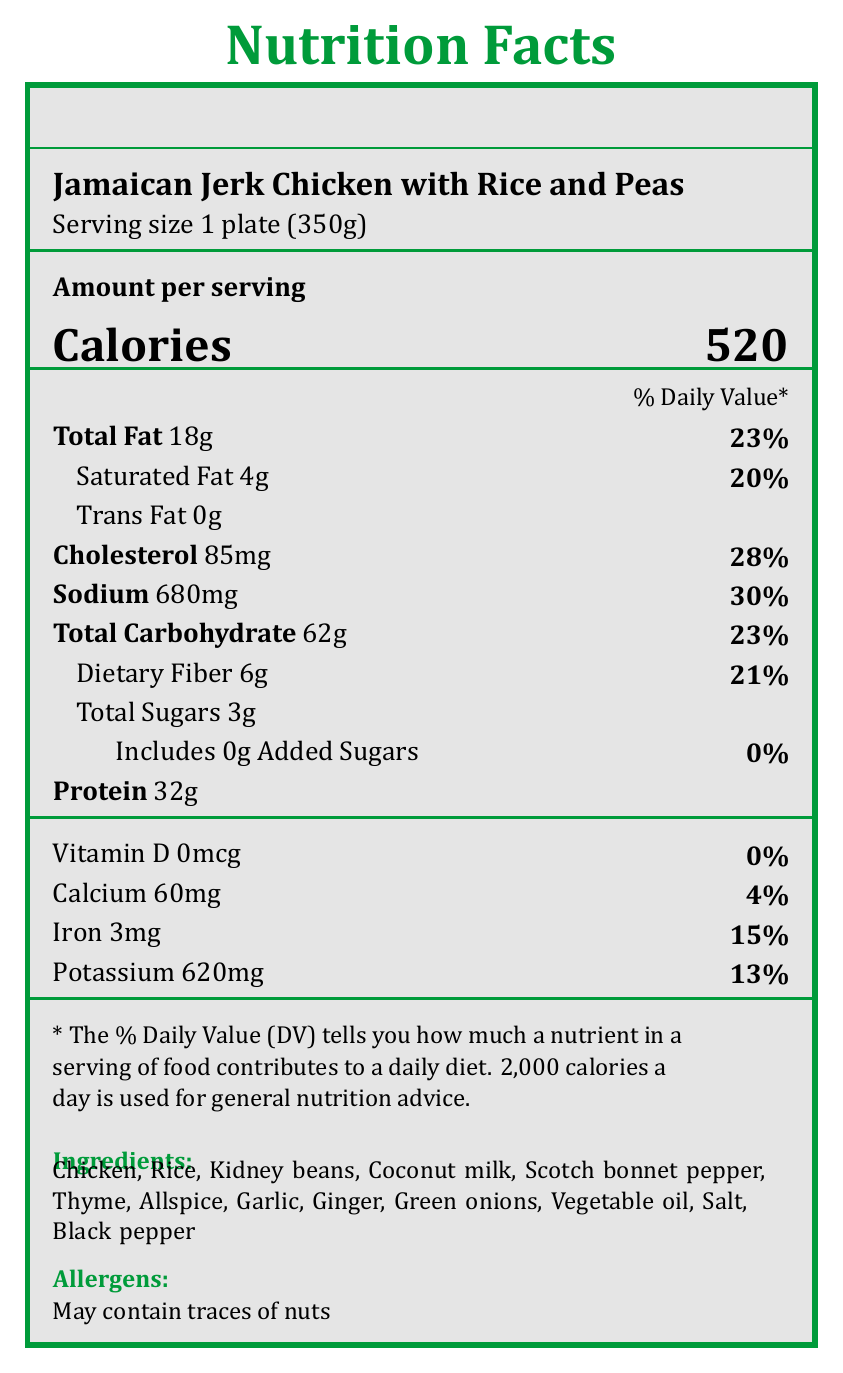what is the serving size for Jamaican Jerk Chicken with Rice and Peas? The serving size is clearly listed as 1 plate (350g) under the dish name in the nutrition facts.
Answer: 1 plate (350g) how many calories does one serving of this dish contain? The calories are prominently displayed as 520 in large font under the "Amount per serving" section.
Answer: 520 what is the amount of total fat in one serving? The total fat content is listed as 18g in the nutrition facts section.
Answer: 18g what percentage of the daily value of sodium does this dish provide? The sodium content is listed as 680mg, which is 30% of the daily value.
Answer: 30% how much protein can be found in a serving of Jamaican Jerk Chicken with Rice and Peas? The protein content is listed as 32g in the nutrition facts.
Answer: 32g what is the daily value percentage of iron provided by this dish? Iron is listed with a daily value percentage of 15%.
Answer: 15% is there any trans fat in this dish? The document lists "Trans Fat 0g", indicating there is no trans fat in the dish.
Answer: No how many grams of dietary fiber does one serving contain? The dietary fiber content in one serving is listed as 6g.
Answer: 6g which of the following ingredients is not listed in the ingredients section? A. Thyme B. Bell Pepper C. Garlic D. Scotch Bonnet Pepper The ingredients list includes thyme, garlic, and scotch bonnet pepper, but not bell pepper.
Answer: B. Bell Pepper what are the allergens mentioned in this dish? The allergens section specifically states "May contain traces of nuts."
Answer: May contain traces of nuts how much calcium is found in one serving? The calcium content is listed as 60mg in the nutrition facts section.
Answer: 60mg describe the cultural significance of Jamaican Jerk Chicken among the Windrush Generation. The historical context section mentions that this dish symbolizes a taste of home and cultural identity for the Windrush Generation.
Answer: Jerk chicken became a staple in British Caribbean communities after the Windrush migration, symbolizing a taste of home and cultural identity. what is the amount of cholesterol in one serving? The cholesterol content is listed as 85mg in the nutrition facts section.
Answer: 85mg which vitamin is reported at 0% daily value? A. Vitamin D B. Vitamin C C. Vitamin A The document lists Vitamin D at 0mcg, which is 0% daily value.
Answer: A. Vitamin D what is the primary cultural adaptation mentioned in the document regarding the recipe? The historical context section notes the adaptation of using bell peppers instead of scotch bonnet due to ingredient availability.
Answer: Some use bell peppers instead of scotch bonnet due to ingredient availability in the UK. does this dish contain any added sugars? The nutrition facts state "Includes 0g Added Sugars", indicating no added sugars.
Answer: No what are the main ingredients of Jamaican Jerk Chicken with Rice and Peas? All these ingredients are listed in the ingredients section of the document.
Answer: Chicken, Rice, Kidney beans, Coconut milk, Scotch bonnet pepper, Thyme, Allspice, Garlic, Ginger, Green onions, Vegetable oil, Salt, Black pepper provide a summary of the Nutrition Facts Label for the traditional Caribbean dish popular among Windrush immigrants. This summary captures the main points of the nutritional content, ingredients, allergens, and historical context found in the document.
Answer: The Nutrition Facts Label details the nutritional composition of Jamaican Jerk Chicken with Rice and Peas, listing a serving size of 1 plate (350g) with 520 calories. The label includes total fat (18g), saturated fat (4g), cholesterol (85mg), sodium (680mg), total carbohydrates (62g), dietary fiber (6g), total sugars (3g), protein (32g), vitamin D (0mcg), calcium (60mg), iron (3mg), and potassium (620mg). Additionally, the document lists the main ingredients and mentions potential allergens. Historically, this dish holds cultural significance among the Windrush Generation as a symbol of home and identity, with some adaptations due to ingredient availability in the UK. how much Vitamin C is present in the dish? The document does not provide any details about Vitamin C content.
Answer: Not enough information what percentage of daily value does saturated fat equate to? Saturated Fat is listed as 4g, which corresponds to 20% of the daily value.
Answer: 20% can someone with nut allergies eat this dish without worry? The allergens section states "May contain traces of nuts," so someone with nut allergies should be cautious.
Answer: No 